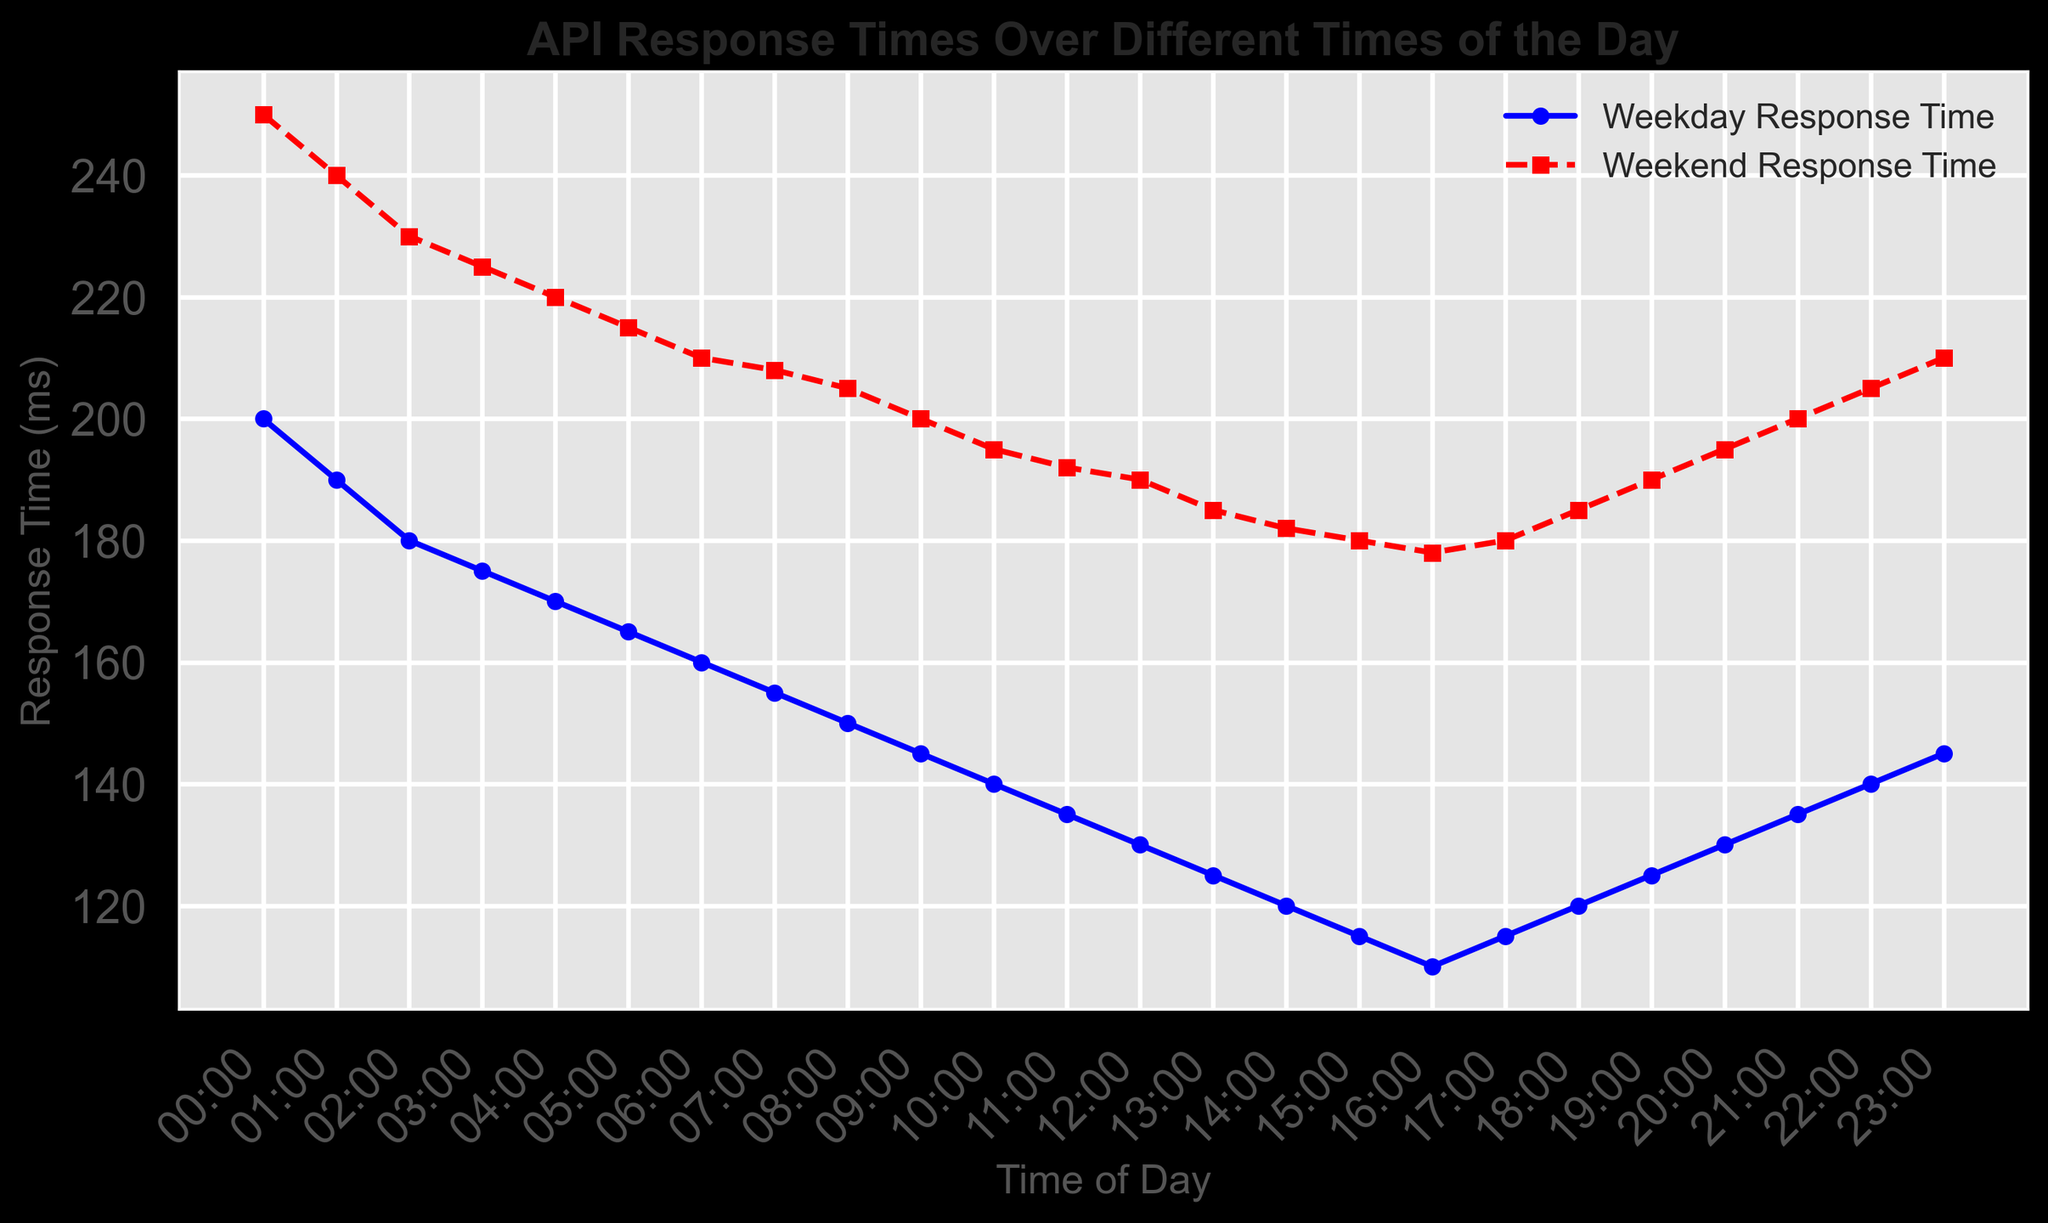Which time of the day shows the largest difference in response times between weekdays and weekends? To find this, subtract the Weekday Response Time from the Weekend Response Time for each time of the day. The largest difference is at 00:00, with (250 - 200 = 50 ms).
Answer: 00:00 During which time slot does the weekday response time reach its lowest value? Observing the dataset, the Weekday Response Time is lowest at 16:00 with a value of 110 ms.
Answer: 16:00 Which period of the day shows the least variation in response times on weekends? Examine the graph to identify the most stable section of Weekend Response Time. The variation is smallest between 10:00 and 12:00, where the line flattens around 195-190 ms.
Answer: 10:00-12:00 At what time is the difference between weekday and weekend response times the smallest? Calculate the difference for each time and identify the minimum value. The smallest difference is at 16:00 with (178 - 110 = 68 ms).
Answer: 16:00 Is there any time of day where the response times are equal or very close for weekdays and weekends? Look for where the lines for Weekday and Weekend Response Times are closest. The closest point is at 07:00 (155 vs 208 ms). Though not equal, this is the closest they come.
Answer: 07:00 During which time of the day do weekends show a peak in response time? Identify the peak value in the Weekend Response Time line. The highest point for weekends is at 00:00 with a response time of 250 ms.
Answer: 00:00 On weekdays, between which time intervals does the response time show a continuous decline? By examining the graph, the response time continuously declines from 00:00 to 16:00 on weekdays.
Answer: 00:00-16:00 How does the response time at 18:00 on weekdays compare to the response time at the same time on weekends? Look at 18:00 on the graph. For weekdays, it's 120 ms, and for weekends, it's 185 ms. Therefore, weekends take longer by (185 - 120 = 65 ms).
Answer: Weekends are 65 ms longer What's the difference in response times between 06:00 and 18:00 on weekends? For 06:00, it is 210 ms and for 18:00, it is 185 ms. The difference is (210 - 185 = 25 ms).
Answer: 25 ms How does the trend of response times during the day differ between weekdays and weekends? Weekday response times show a continuous decline from 00:00 to 16:00, followed by minor fluctuations. The weekends also decline but start higher and vary more consistently throughout the day.
Answer: Weekdays decline more sharply in the morning 